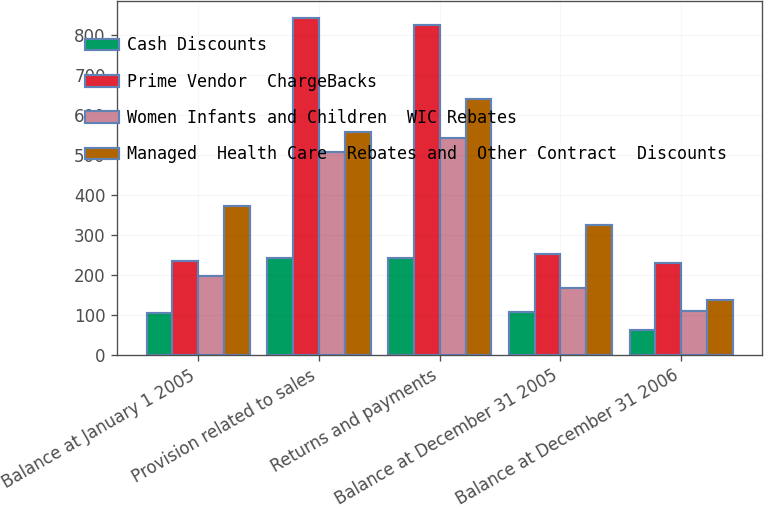<chart> <loc_0><loc_0><loc_500><loc_500><stacked_bar_chart><ecel><fcel>Balance at January 1 2005<fcel>Provision related to sales<fcel>Returns and payments<fcel>Balance at December 31 2005<fcel>Balance at December 31 2006<nl><fcel>Cash Discounts<fcel>106<fcel>243<fcel>243<fcel>107<fcel>63<nl><fcel>Prime Vendor  ChargeBacks<fcel>234<fcel>843<fcel>825<fcel>252<fcel>230<nl><fcel>Women Infants and Children  WIC Rebates<fcel>198<fcel>509<fcel>542<fcel>167<fcel>111<nl><fcel>Managed  Health Care  Rebates and  Other Contract  Discounts<fcel>372<fcel>558<fcel>641<fcel>326<fcel>137<nl></chart> 